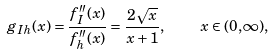Convert formula to latex. <formula><loc_0><loc_0><loc_500><loc_500>g _ { I h } ( x ) = \frac { { f } ^ { \prime \prime } _ { I } ( x ) } { { f } ^ { \prime \prime } _ { h } ( x ) } = \frac { 2 \sqrt { x } } { x + 1 } , \quad x \in ( 0 , \infty ) ,</formula> 